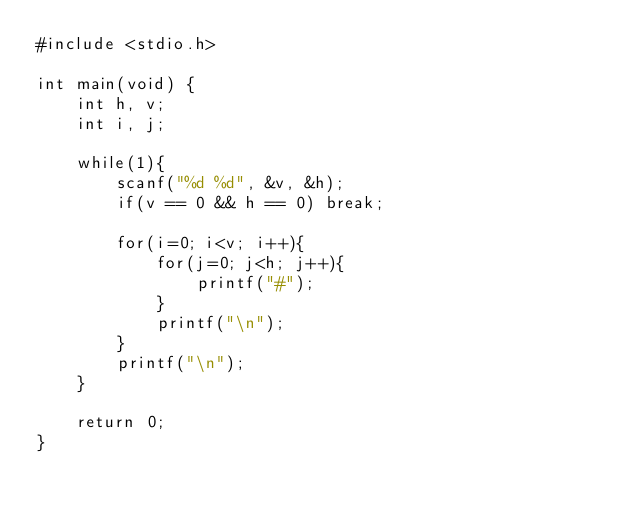<code> <loc_0><loc_0><loc_500><loc_500><_C_>#include <stdio.h>

int main(void) {
    int h, v;
    int i, j;

    while(1){
        scanf("%d %d", &v, &h);
        if(v == 0 && h == 0) break;
        
        for(i=0; i<v; i++){
            for(j=0; j<h; j++){
                printf("#");
            }
            printf("\n");
        }
        printf("\n");
    }

    return 0;
}</code> 